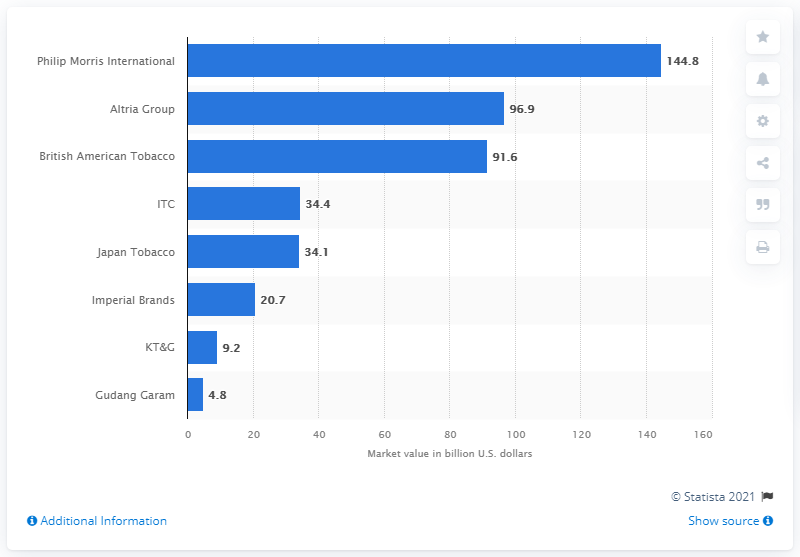Draw attention to some important aspects in this diagram. In 2020, British American Tobacco's global market value was approximately 91.6 billion U.S. dollars. In 2020, Philip Morris International was the largest tobacco company in the world. 